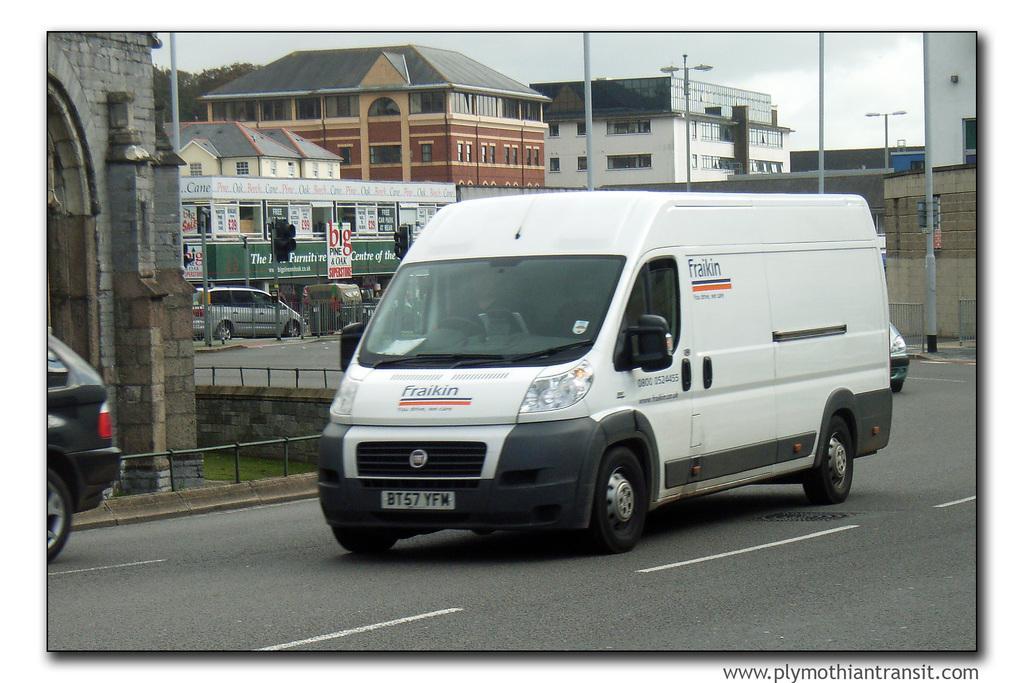Please provide a concise description of this image. In this picture we can see vehicles on the road, fences, traffic signals, posters, buildings, windows, light poles, trees, walls and some objects and in the background we can see the sky. 